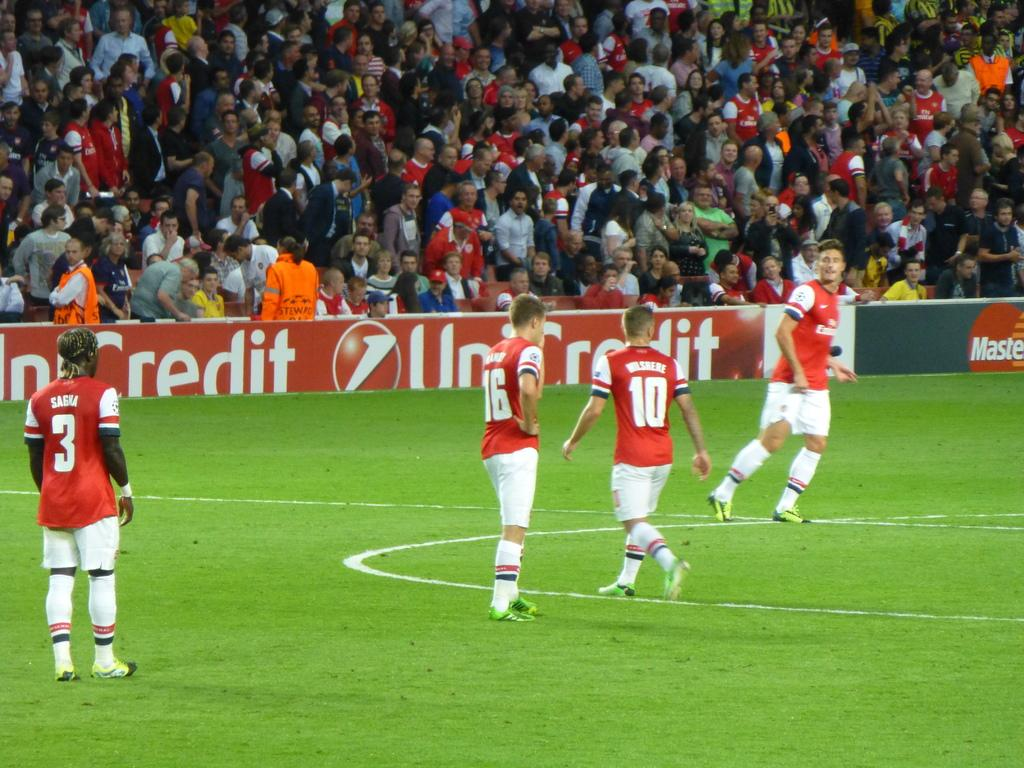Provide a one-sentence caption for the provided image. A group of soccer players in red jerseys are playing in front of a packed crowd at Mastercard Stadium. 